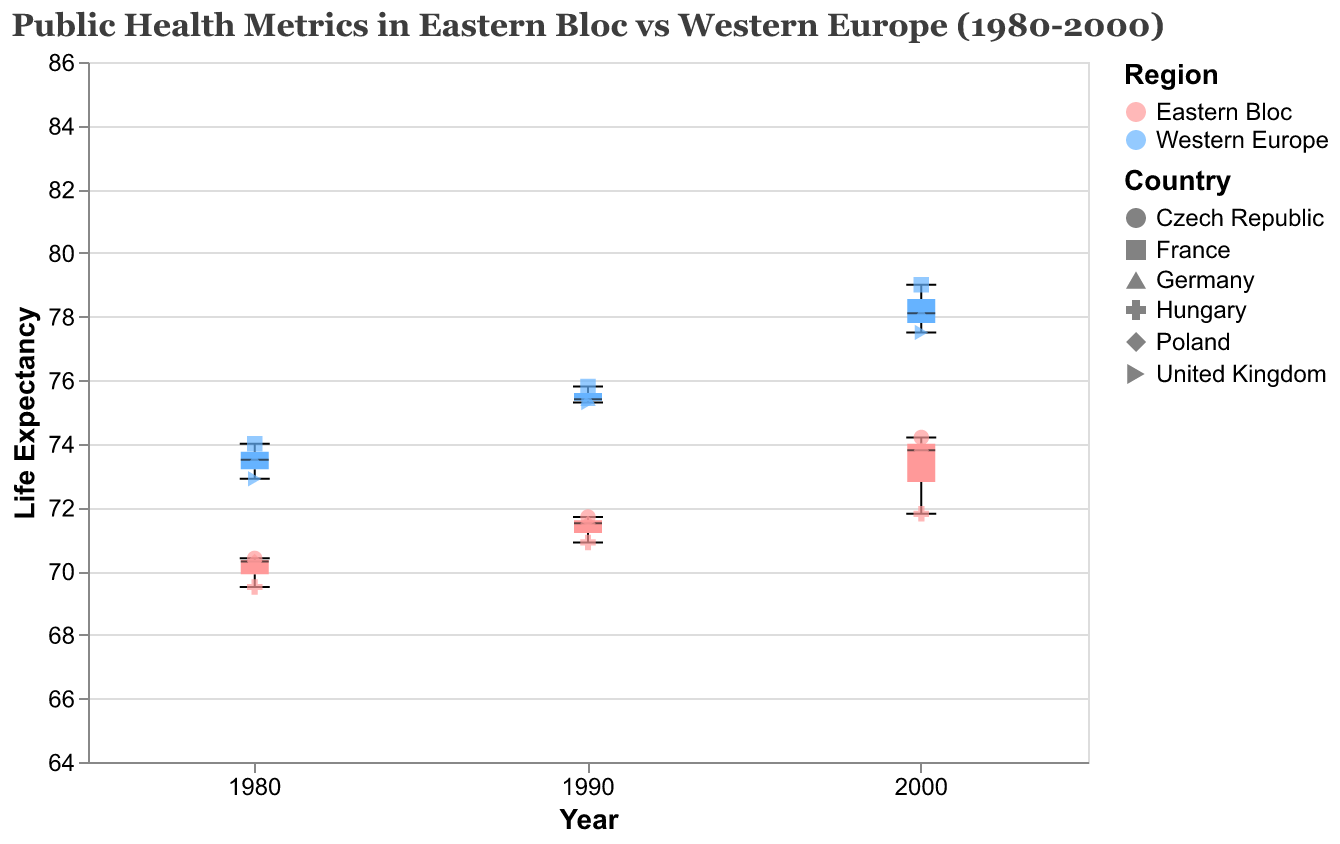What is the title of the figure? The title is typically located at the top of the figure, showcasing the main purpose or subject of the visual.
Answer: Public Health Metrics in Eastern Bloc vs Western Europe (1980-2000) What is the highest life expectancy value in the Western Europe region in 2000? To determine this, observe the scatter plot points for Western Europe in the year 2000. Look for the point with the highest vertical position.
Answer: 79.0 How does the box plot of life expectancy in Eastern Bloc countries in 1980 compare to that of 2000? Compare the position and spread of the box plots for Eastern Bloc countries in 1980 and 2000. Check the median line and the length of the boxes (interquartile range).
Answer: The 2000 box plot shows a higher median and less variability than the 1980 box plot Which region shows lower infant mortality in the year 1990, and what are the key differences? Look at the color-coded scatter points for infant mortality in 1990. Compare the positions of the points for each region.
Answer: Western Europe shows lower infant mortality in 1990. Western Europe's points are around 6.0 to 7.9, whereas Eastern Bloc is around 11.5 to 19.1 What is the range of life expectancy in Eastern Bloc countries in 1990? To determine the range, find the minimum and maximum values for life expectancy in Eastern Bloc countries in 1990.
Answer: 70.9 to 71.7 Is there a general trend in life expectancy from 1980 to 2000 across the regions? Look at the changes in life expectancy points from 1980 to 2000 for both regions. Note any upward or downward trends over the years.
Answer: Increasing trend in both regions How does the variability in life expectancy compare between the Eastern Bloc and Western Europe in 1980? Compare the interquartile ranges (the box lengths) of life expectancy for the two regions in 1980.
Answer: Western Europe shows less variability Which country had the largest improvement in life expectancy from 1980 to 2000, and what was the amount of increase? Find the differences in life expectancy from 1980 to 2000 for each country and identify the largest value.
Answer: France, with an increase of 5.0 years (from 74.0 to 79.0) Among Eastern Bloc countries, which had the lowest infant mortality rate in 2000? Compare the scatter points in the Eastern Bloc of 2000, focusing on the infant mortality values, and identify the lowest one.
Answer: Czech Republic, 5.8 